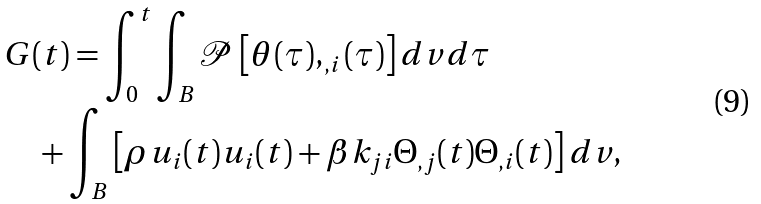Convert formula to latex. <formula><loc_0><loc_0><loc_500><loc_500>& G ( t ) = \int _ { 0 } ^ { t } \int _ { B } \mathcal { \mathcal { P } } \left [ \theta ( \tau ) , _ { , i } ( \tau ) \right ] d v d \tau \\ & \quad + \int _ { B } \left [ \rho u _ { i } ( t ) u _ { i } ( t ) + \beta k _ { j i } \Theta _ { , j } ( t ) \Theta _ { , i } ( t ) \right ] d v ,</formula> 